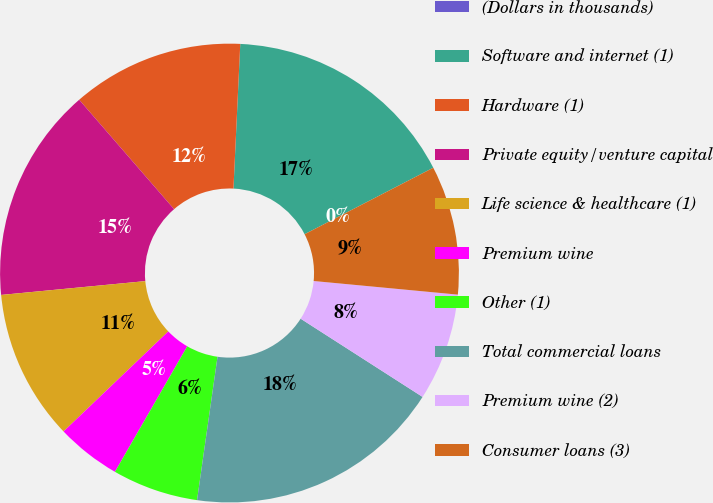Convert chart to OTSL. <chart><loc_0><loc_0><loc_500><loc_500><pie_chart><fcel>(Dollars in thousands)<fcel>Software and internet (1)<fcel>Hardware (1)<fcel>Private equity/venture capital<fcel>Life science & healthcare (1)<fcel>Premium wine<fcel>Other (1)<fcel>Total commercial loans<fcel>Premium wine (2)<fcel>Consumer loans (3)<nl><fcel>0.0%<fcel>16.66%<fcel>12.12%<fcel>15.15%<fcel>10.61%<fcel>4.55%<fcel>6.06%<fcel>18.18%<fcel>7.58%<fcel>9.09%<nl></chart> 